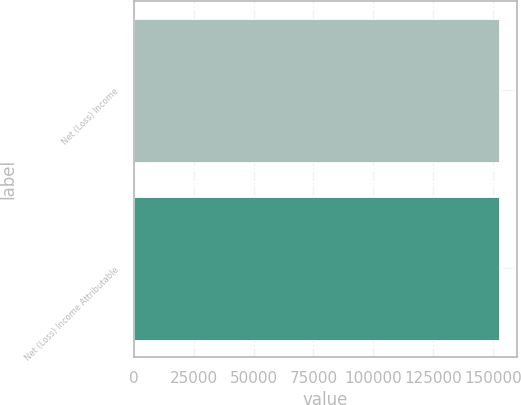Convert chart. <chart><loc_0><loc_0><loc_500><loc_500><bar_chart><fcel>Net (Loss) Income<fcel>Net (Loss) Income Attributable<nl><fcel>152432<fcel>152432<nl></chart> 